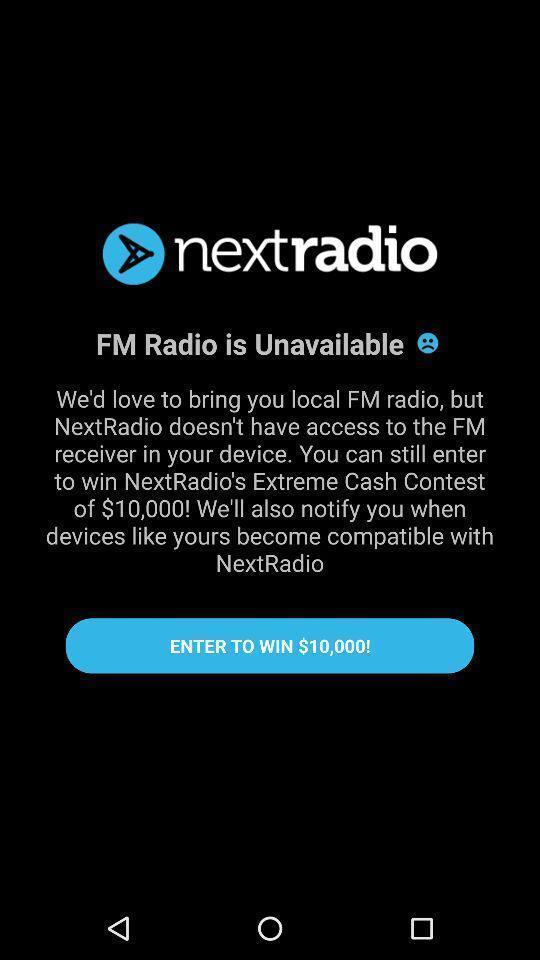Please provide a description for this image. Welcome page of a radio application. 